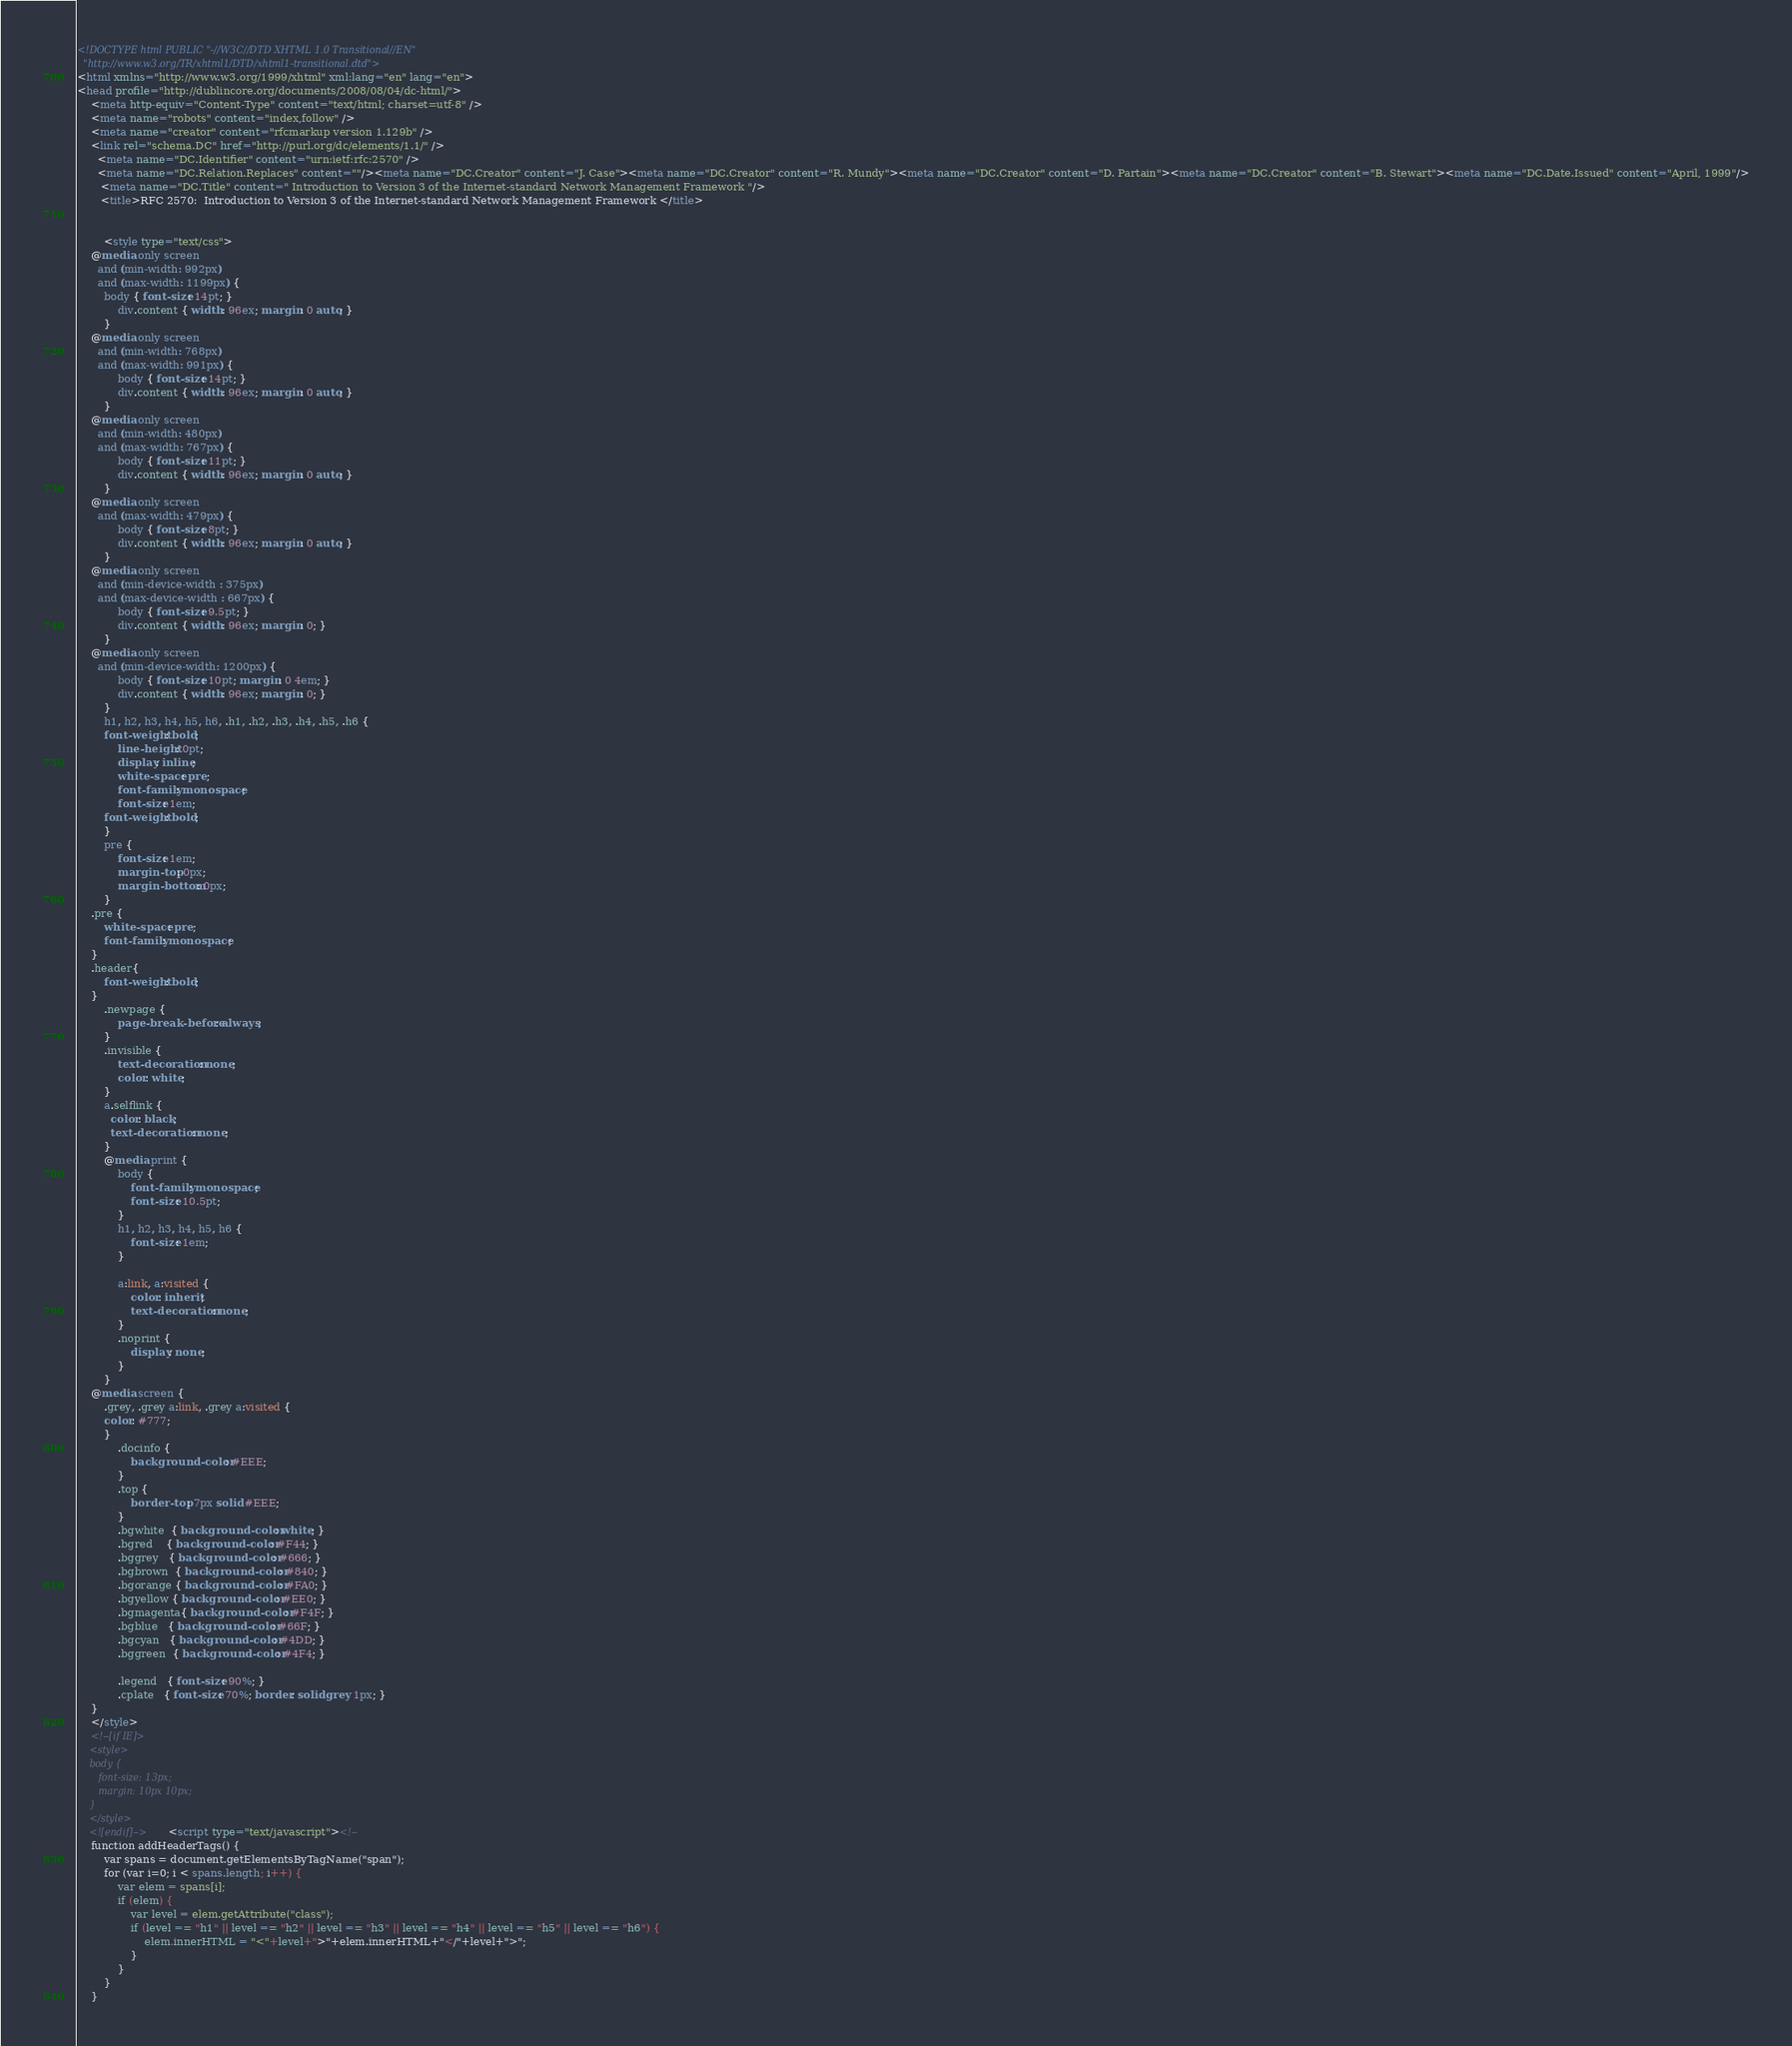Convert code to text. <code><loc_0><loc_0><loc_500><loc_500><_HTML_><!DOCTYPE html PUBLIC "-//W3C//DTD XHTML 1.0 Transitional//EN"
  "http://www.w3.org/TR/xhtml1/DTD/xhtml1-transitional.dtd">
<html xmlns="http://www.w3.org/1999/xhtml" xml:lang="en" lang="en">
<head profile="http://dublincore.org/documents/2008/08/04/dc-html/">
    <meta http-equiv="Content-Type" content="text/html; charset=utf-8" />
    <meta name="robots" content="index,follow" />
    <meta name="creator" content="rfcmarkup version 1.129b" />
    <link rel="schema.DC" href="http://purl.org/dc/elements/1.1/" />
      <meta name="DC.Identifier" content="urn:ietf:rfc:2570" />
      <meta name="DC.Relation.Replaces" content=""/><meta name="DC.Creator" content="J. Case"><meta name="DC.Creator" content="R. Mundy"><meta name="DC.Creator" content="D. Partain"><meta name="DC.Creator" content="B. Stewart"><meta name="DC.Date.Issued" content="April, 1999"/>
       <meta name="DC.Title" content=" Introduction to Version 3 of the Internet-standard Network Management Framework "/>
       <title>RFC 2570:  Introduction to Version 3 of the Internet-standard Network Management Framework </title>    
        

        <style type="text/css">
	@media only screen 
	  and (min-width: 992px)
	  and (max-width: 1199px) {
	    body { font-size: 14pt; }
            div.content { width: 96ex; margin: 0 auto; }
        }
	@media only screen 
	  and (min-width: 768px)
	  and (max-width: 991px) {
            body { font-size: 14pt; }
            div.content { width: 96ex; margin: 0 auto; }
        }
	@media only screen 
	  and (min-width: 480px)
	  and (max-width: 767px) {
            body { font-size: 11pt; }
            div.content { width: 96ex; margin: 0 auto; }
        }
	@media only screen 
	  and (max-width: 479px) {
            body { font-size: 8pt; }
            div.content { width: 96ex; margin: 0 auto; }
        }
	@media only screen 
	  and (min-device-width : 375px) 
	  and (max-device-width : 667px) {
            body { font-size: 9.5pt; }
            div.content { width: 96ex; margin: 0; }
        }
	@media only screen 
	  and (min-device-width: 1200px) {
            body { font-size: 10pt; margin: 0 4em; }
            div.content { width: 96ex; margin: 0; }
        }
        h1, h2, h3, h4, h5, h6, .h1, .h2, .h3, .h4, .h5, .h6 {
	    font-weight: bold;
            line-height: 0pt;
            display: inline;
            white-space: pre;
            font-family: monospace;
            font-size: 1em;
	    font-weight: bold;
        }
        pre {
            font-size: 1em;
            margin-top: 0px;
            margin-bottom: 0px;
        }
	.pre {
	    white-space: pre;
	    font-family: monospace;
	}
	.header{
	    font-weight: bold;
	}
        .newpage {
            page-break-before: always;
        }
        .invisible {
            text-decoration: none;
            color: white;
        }
        a.selflink {
          color: black;
          text-decoration: none;
        }
        @media print {
            body {
                font-family: monospace;
                font-size: 10.5pt;
            }
            h1, h2, h3, h4, h5, h6 {
                font-size: 1em;
            }
        
            a:link, a:visited {
                color: inherit;
                text-decoration: none;
            }
            .noprint {
                display: none;
            }
        }
	@media screen {
	    .grey, .grey a:link, .grey a:visited {
		color: #777;
	    }
            .docinfo {
                background-color: #EEE;
            }
            .top {
                border-top: 7px solid #EEE;
            }
            .bgwhite  { background-color: white; }
            .bgred    { background-color: #F44; }
            .bggrey   { background-color: #666; }
            .bgbrown  { background-color: #840; }            
            .bgorange { background-color: #FA0; }
            .bgyellow { background-color: #EE0; }
            .bgmagenta{ background-color: #F4F; }
            .bgblue   { background-color: #66F; }
            .bgcyan   { background-color: #4DD; }
            .bggreen  { background-color: #4F4; }

            .legend   { font-size: 90%; }
            .cplate   { font-size: 70%; border: solid grey 1px; }
	}
    </style>
    <!--[if IE]>
    <style>
    body {
       font-size: 13px;
       margin: 10px 10px;
    }
    </style>
    <![endif]-->    <script type="text/javascript"><!--
    function addHeaderTags() {
        var spans = document.getElementsByTagName("span");
        for (var i=0; i < spans.length; i++) {
            var elem = spans[i];
            if (elem) {
                var level = elem.getAttribute("class");
                if (level == "h1" || level == "h2" || level == "h3" || level == "h4" || level == "h5" || level == "h6") {
                    elem.innerHTML = "<"+level+">"+elem.innerHTML+"</"+level+">";               
                }
            }
        }
    }</code> 